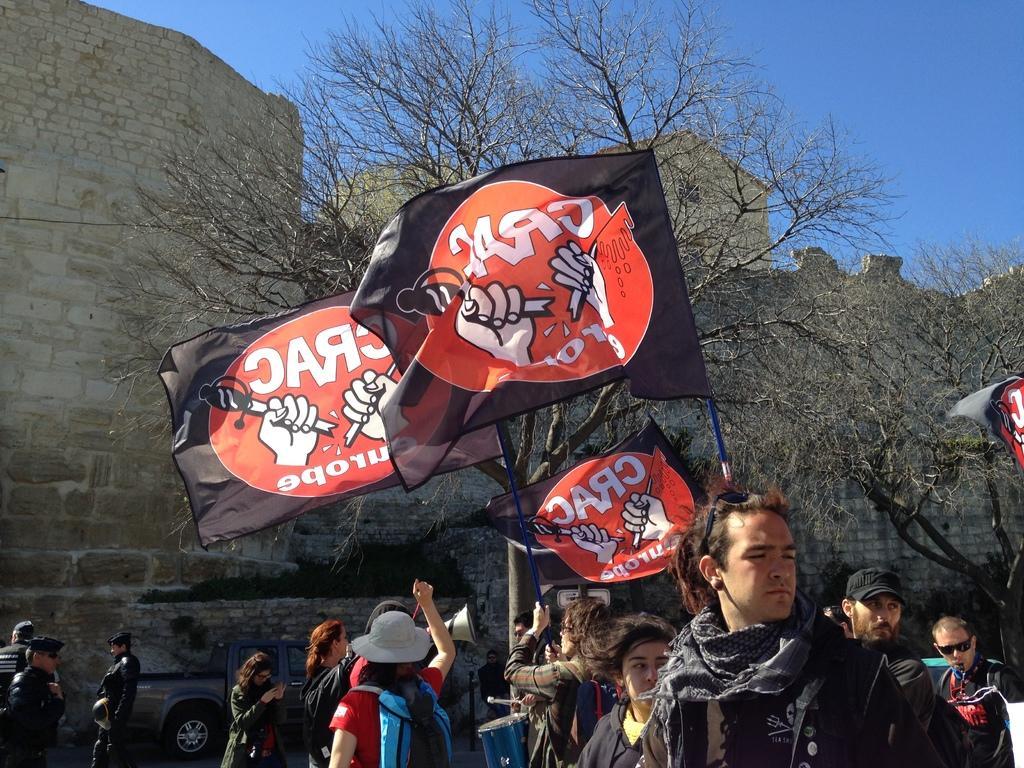Could you give a brief overview of what you see in this image? In this image there is a vehicle near the wall. Bottom of the image there are few people. Few people are holding the flags. A person is holding a sound speaker. Background there is a wall. Before it there are trees. Top of the image there is sky. A person is playing a musical instrument. 